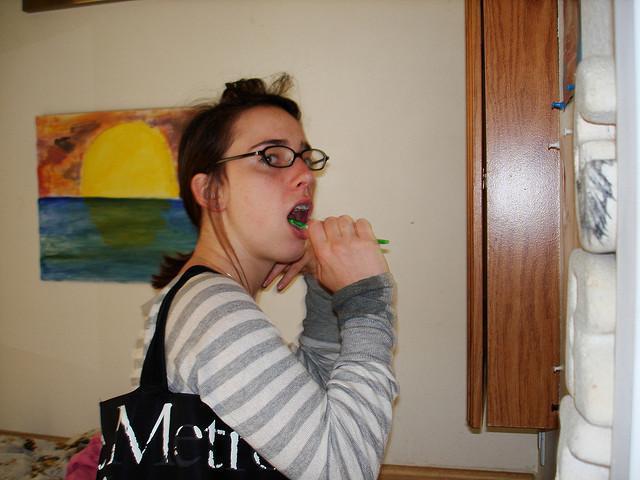How many people are here?
Give a very brief answer. 1. 